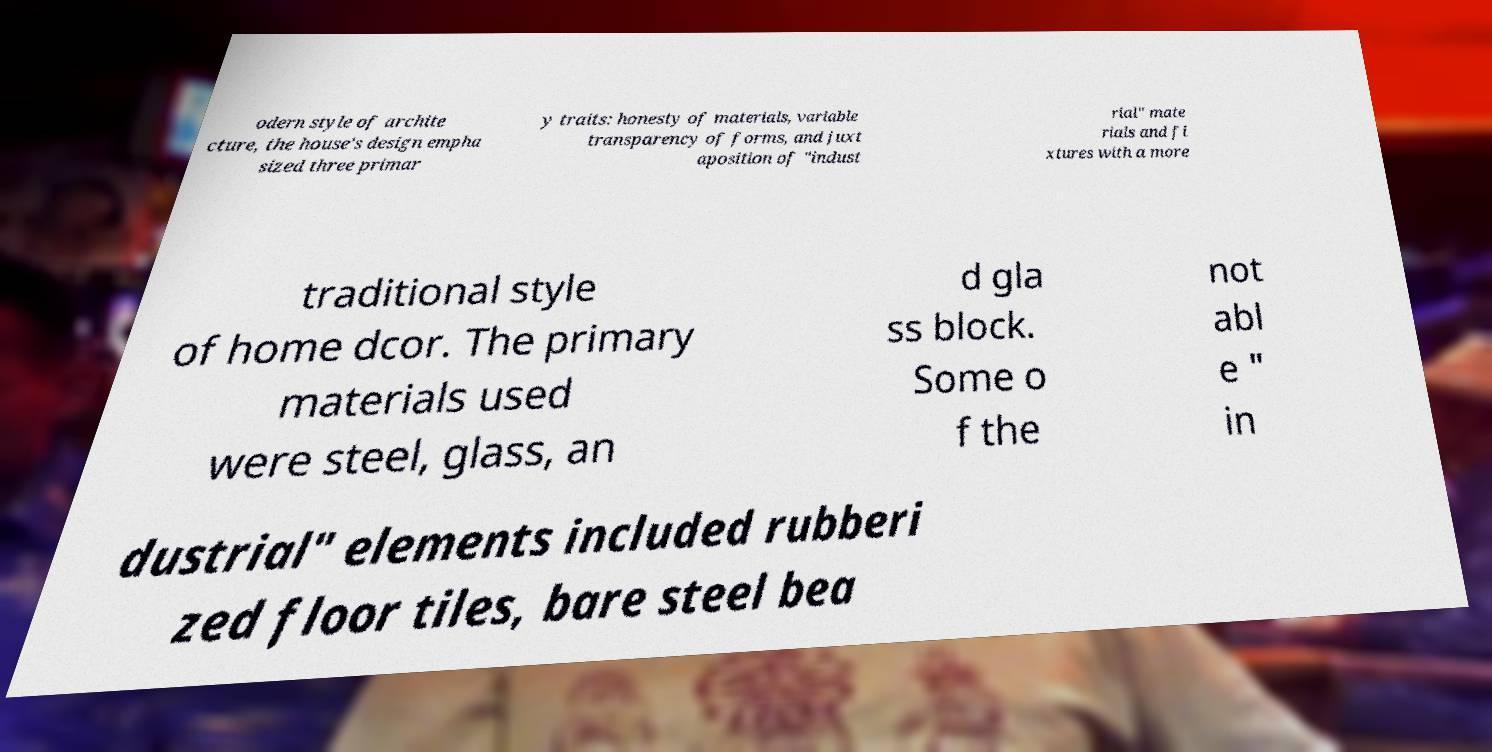What messages or text are displayed in this image? I need them in a readable, typed format. odern style of archite cture, the house's design empha sized three primar y traits: honesty of materials, variable transparency of forms, and juxt aposition of "indust rial" mate rials and fi xtures with a more traditional style of home dcor. The primary materials used were steel, glass, an d gla ss block. Some o f the not abl e " in dustrial" elements included rubberi zed floor tiles, bare steel bea 